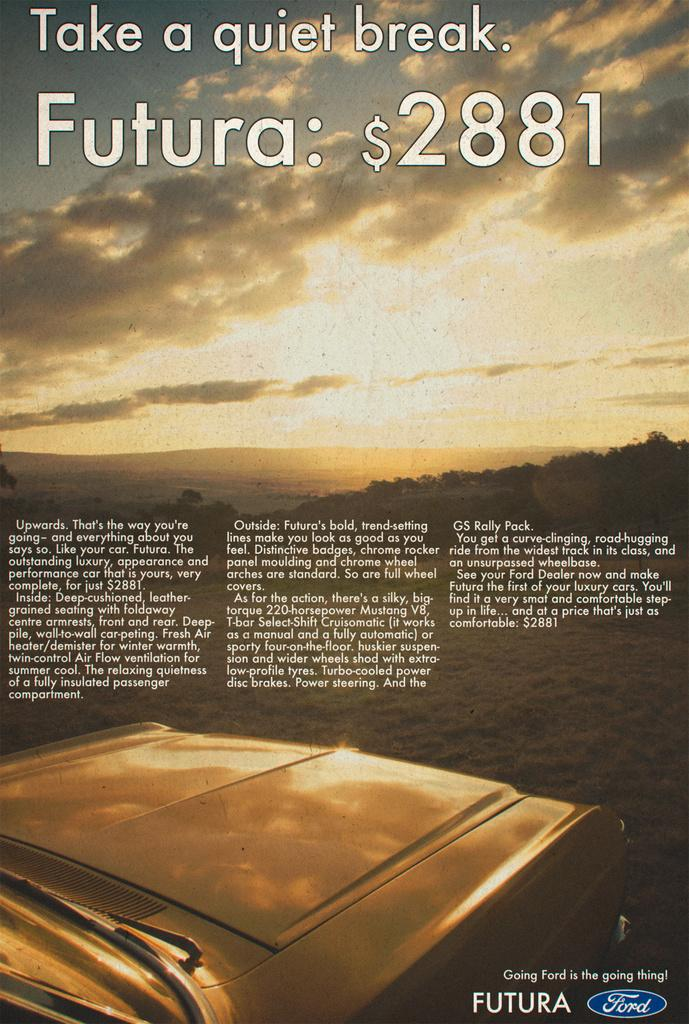<image>
Give a short and clear explanation of the subsequent image. An advertisement from Ford that reads Take a quiet break. Futura: $2881. 